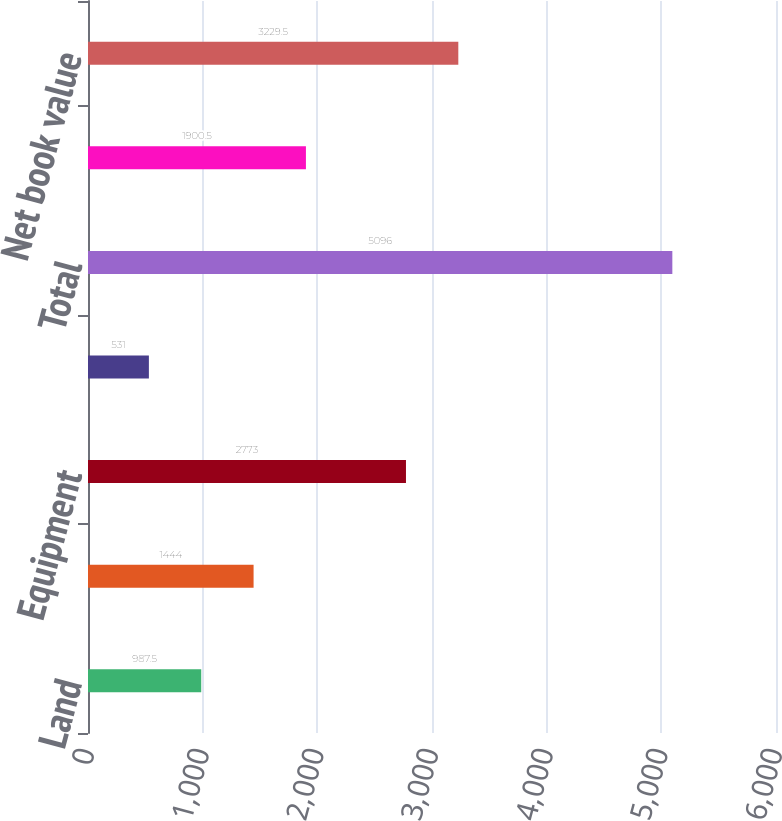Convert chart. <chart><loc_0><loc_0><loc_500><loc_500><bar_chart><fcel>Land<fcel>Buildings<fcel>Equipment<fcel>Leasehold improvements<fcel>Total<fcel>Accumulated depreciation and<fcel>Net book value<nl><fcel>987.5<fcel>1444<fcel>2773<fcel>531<fcel>5096<fcel>1900.5<fcel>3229.5<nl></chart> 